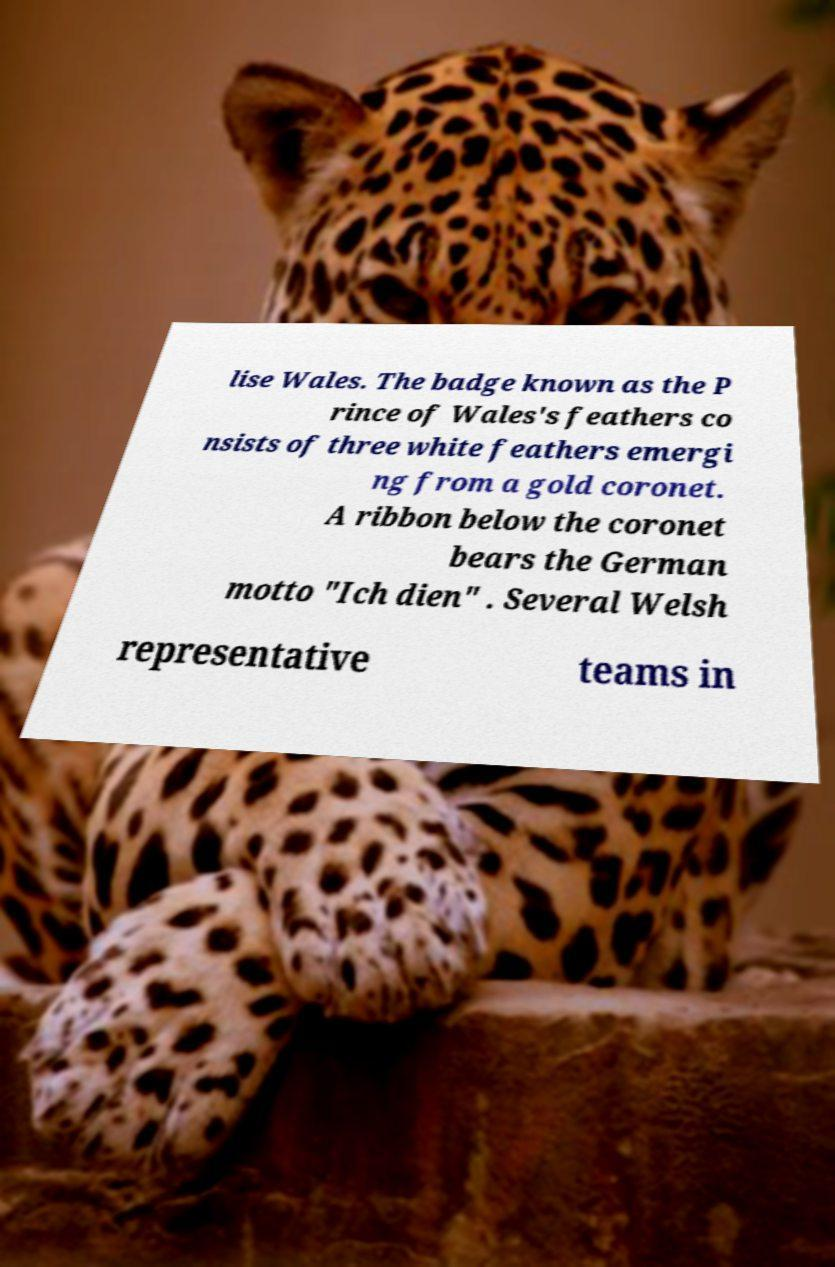I need the written content from this picture converted into text. Can you do that? lise Wales. The badge known as the P rince of Wales's feathers co nsists of three white feathers emergi ng from a gold coronet. A ribbon below the coronet bears the German motto "Ich dien" . Several Welsh representative teams in 